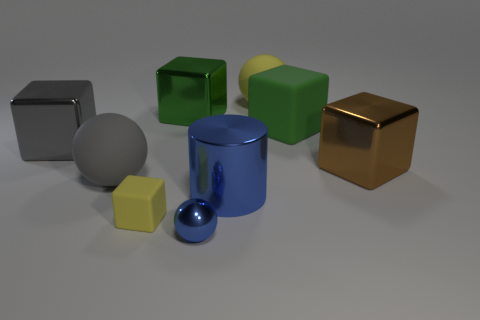Is there anything else that has the same shape as the large blue thing?
Ensure brevity in your answer.  No. Do the matte block in front of the big gray sphere and the rubber cube right of the cylinder have the same size?
Your answer should be compact. No. What is the yellow object to the left of the yellow object that is to the right of the big green metal cube made of?
Your response must be concise. Rubber. Are there fewer big green rubber cubes that are on the left side of the large blue object than big green things?
Keep it short and to the point. Yes. What shape is the big green thing that is the same material as the gray sphere?
Offer a very short reply. Cube. What number of other things are the same shape as the big blue metallic thing?
Provide a succinct answer. 0. What number of gray things are large metal blocks or big rubber blocks?
Make the answer very short. 1. Do the tiny blue metal object and the big yellow object have the same shape?
Your response must be concise. Yes. There is a metallic object left of the gray matte thing; are there any yellow cubes in front of it?
Provide a short and direct response. Yes. Is the number of green cubes that are in front of the gray rubber thing the same as the number of big red cylinders?
Keep it short and to the point. Yes. 